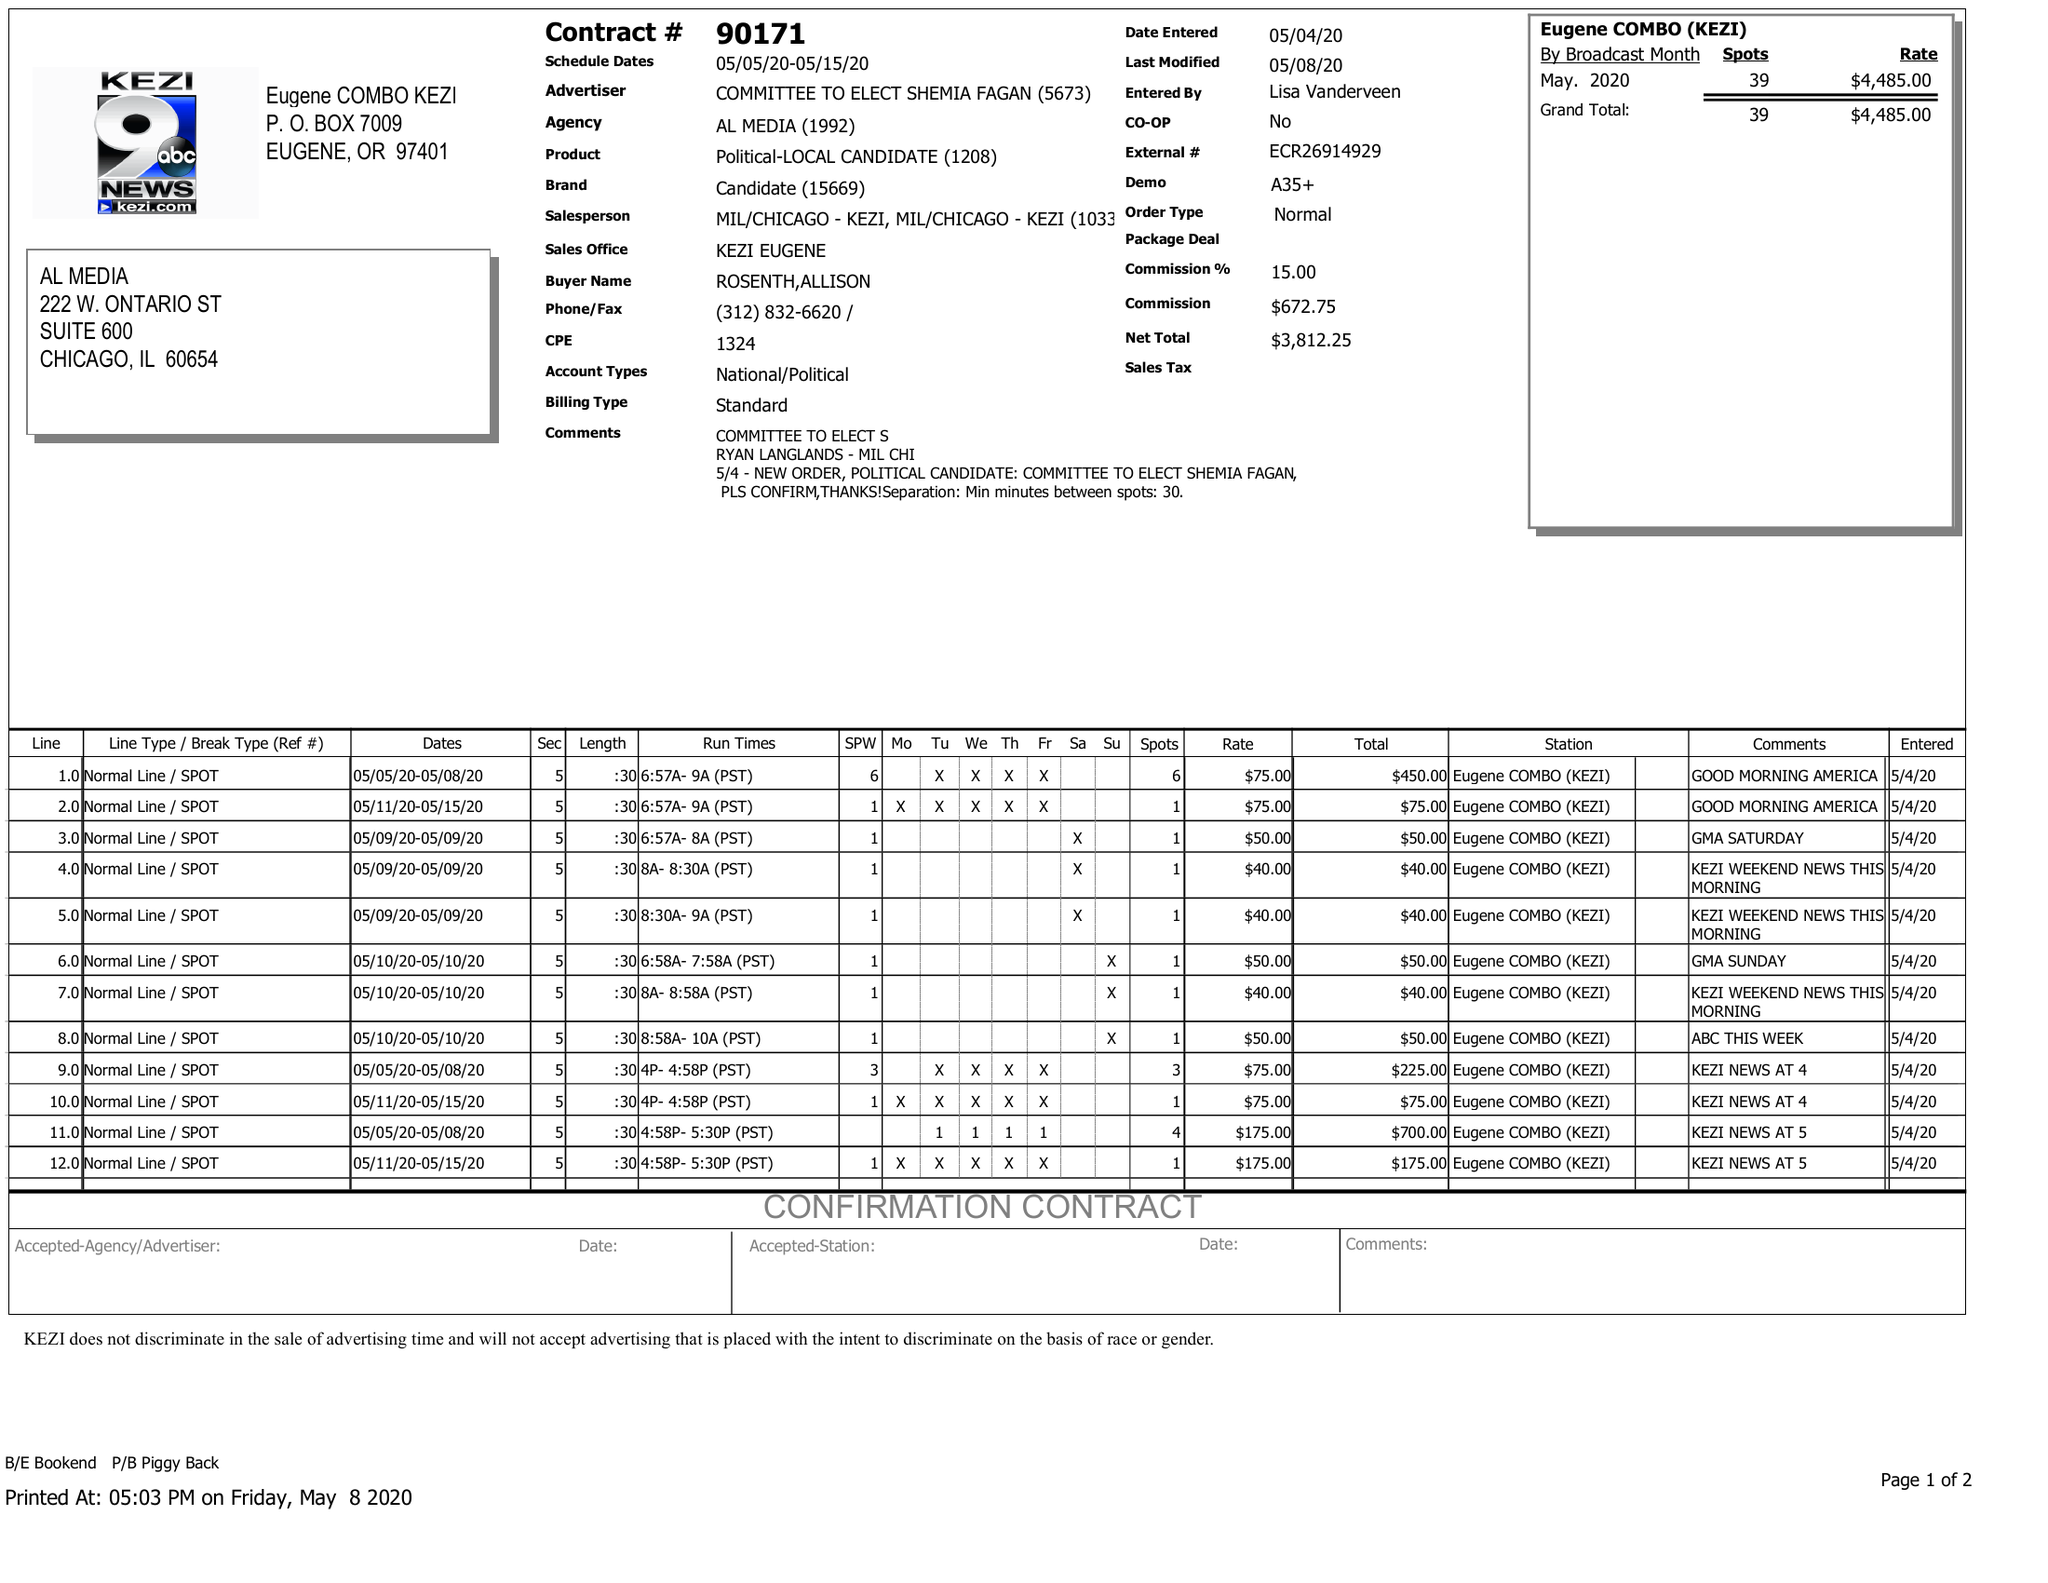What is the value for the flight_to?
Answer the question using a single word or phrase. 05/15/20 